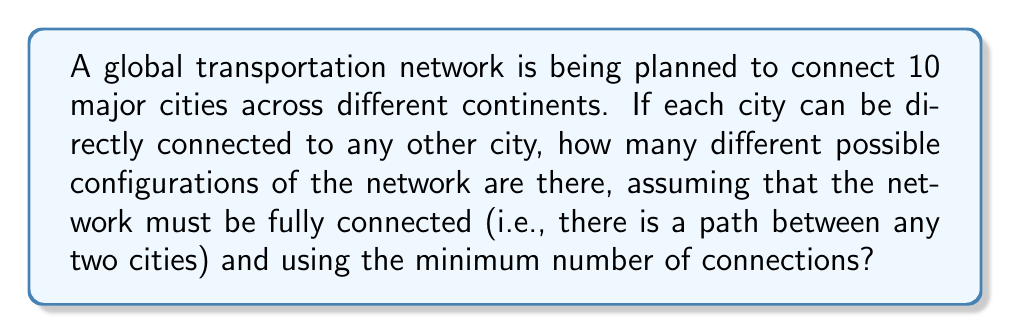Help me with this question. To solve this problem, we need to use Cayley's formula for the number of spanning trees in a complete graph. The steps are as follows:

1. Recognize that the cities form a complete graph, where each city can be connected to any other city.

2. The minimum number of connections to fully connect 10 cities is 9, forming a spanning tree.

3. Cayley's formula states that for a complete graph with $n$ vertices, the number of spanning trees is $n^{n-2}$.

4. In this case, $n = 10$ (number of cities).

5. Apply Cayley's formula:
   Number of spanning trees = $10^{10-2} = 10^8$

Therefore, there are $10^8$ different possible configurations for the global transportation network connecting 10 cities with the minimum number of connections.
Answer: $10^8$ 